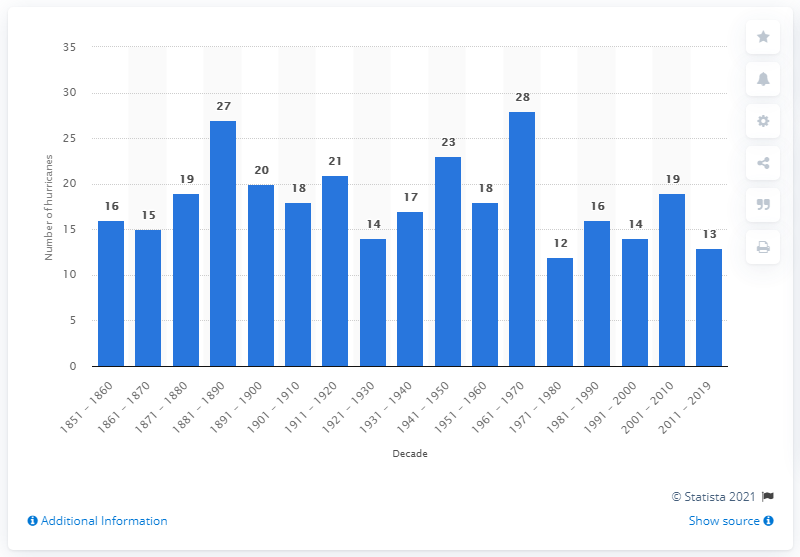Indicate a few pertinent items in this graphic. During the period of 2011 to 2019, a total of 13 hurricanes made landfall in the United States. 